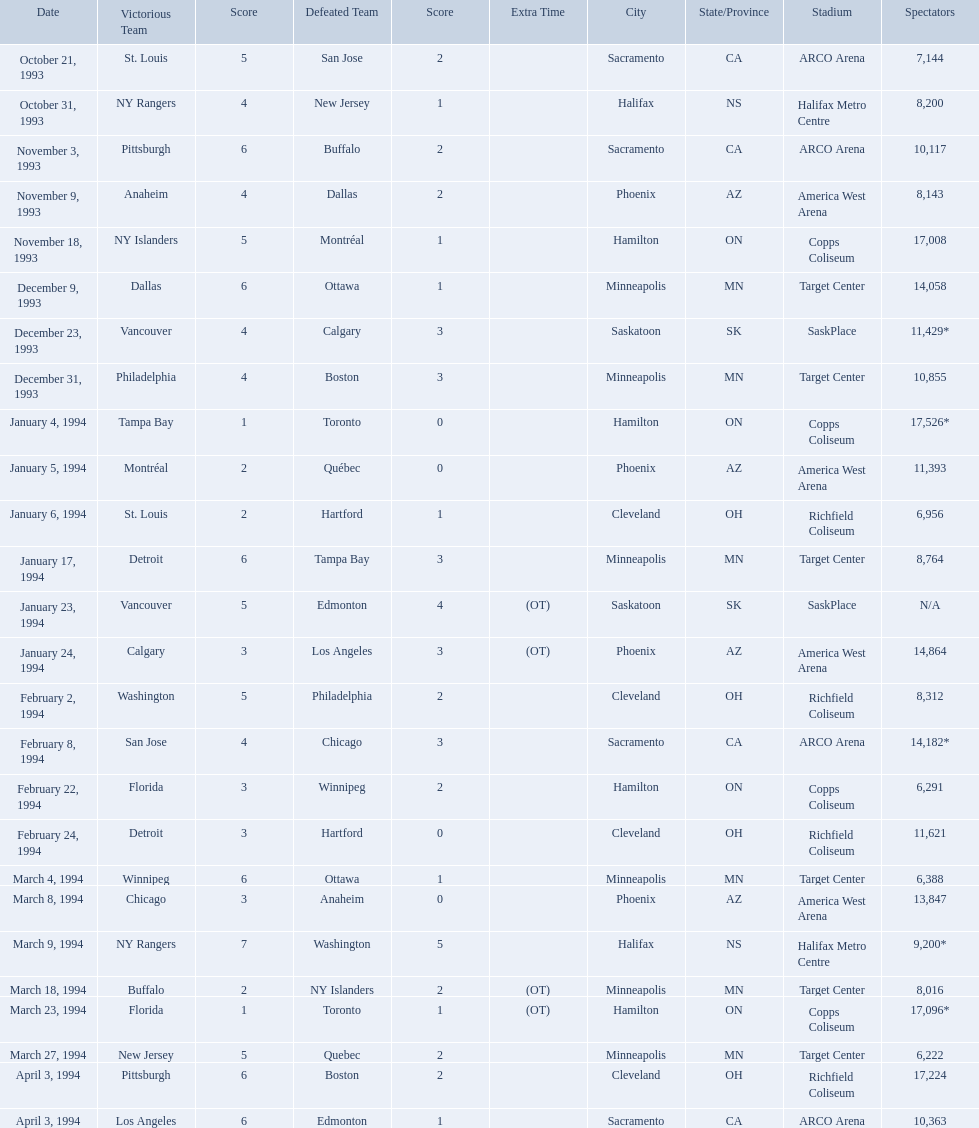What was the attendance on january 24, 1994? 14,864. What was the attendance on december 23, 1993? 11,429*. Between january 24, 1994 and december 23, 1993, which had the higher attendance? January 4, 1994. On which dates were all the games? October 21, 1993, October 31, 1993, November 3, 1993, November 9, 1993, November 18, 1993, December 9, 1993, December 23, 1993, December 31, 1993, January 4, 1994, January 5, 1994, January 6, 1994, January 17, 1994, January 23, 1994, January 24, 1994, February 2, 1994, February 8, 1994, February 22, 1994, February 24, 1994, March 4, 1994, March 8, 1994, March 9, 1994, March 18, 1994, March 23, 1994, March 27, 1994, April 3, 1994, April 3, 1994. What were the attendances? 7,144, 8,200, 10,117, 8,143, 17,008, 14,058, 11,429*, 10,855, 17,526*, 11,393, 6,956, 8,764, N/A, 14,864, 8,312, 14,182*, 6,291, 11,621, 6,388, 13,847, 9,200*, 8,016, 17,096*, 6,222, 17,224, 10,363. And between december 23, 1993 and january 24, 1994, which game had the highest turnout? January 4, 1994. Which was the highest attendance for a game? 17,526*. What was the date of the game with an attendance of 17,526? January 4, 1994. When were the games played? October 21, 1993, October 31, 1993, November 3, 1993, November 9, 1993, November 18, 1993, December 9, 1993, December 23, 1993, December 31, 1993, January 4, 1994, January 5, 1994, January 6, 1994, January 17, 1994, January 23, 1994, January 24, 1994, February 2, 1994, February 8, 1994, February 22, 1994, February 24, 1994, March 4, 1994, March 8, 1994, March 9, 1994, March 18, 1994, March 23, 1994, March 27, 1994, April 3, 1994, April 3, 1994. What was the attendance for those games? 7,144, 8,200, 10,117, 8,143, 17,008, 14,058, 11,429*, 10,855, 17,526*, 11,393, 6,956, 8,764, N/A, 14,864, 8,312, 14,182*, 6,291, 11,621, 6,388, 13,847, 9,200*, 8,016, 17,096*, 6,222, 17,224, 10,363. Which date had the highest attendance? January 4, 1994. 